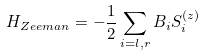<formula> <loc_0><loc_0><loc_500><loc_500>H _ { Z e e m a n } = - \frac { 1 } { 2 } \sum _ { i = l , r } B _ { i } S ^ { ( z ) } _ { i }</formula> 